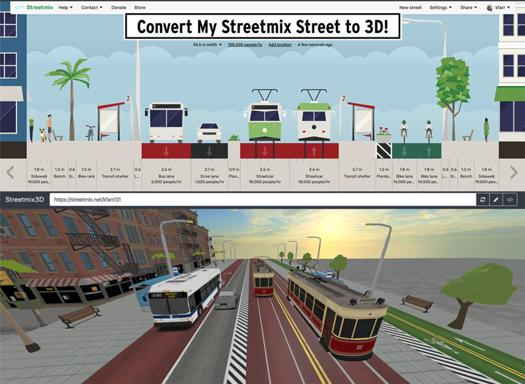What is the purpose of the text in the image? The text in the image announces a feature that allows users to transform their custom Streetmix street designs into dynamic 3D models. This function not only adds visual depth but also helps in planning and envisioning urban spaces more effectively. 